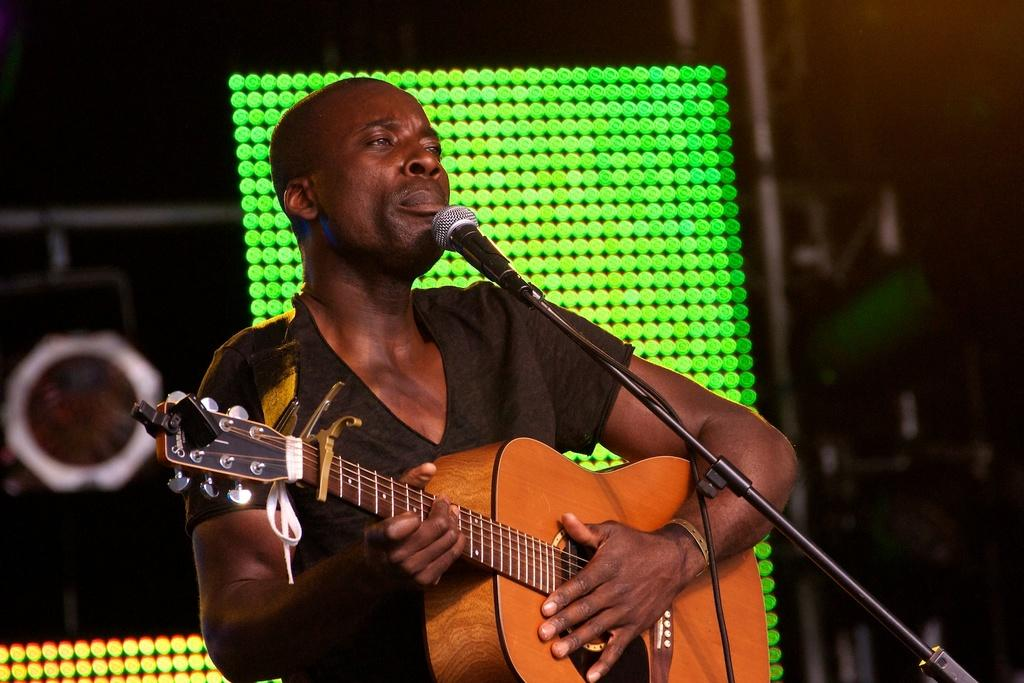What is the main subject of the image? There is a man in the image. What is the man wearing? The man is wearing a black t-shirt. What is the man doing in the image? The man is standing and playing a guitar. What object is in front of the man? There is a microphone in front of the man. What can be seen behind the man? There is a green light at the back of the man. What direction is the tramp jumping in the image? There is no tramp present in the image, so it is not possible to answer that question. 